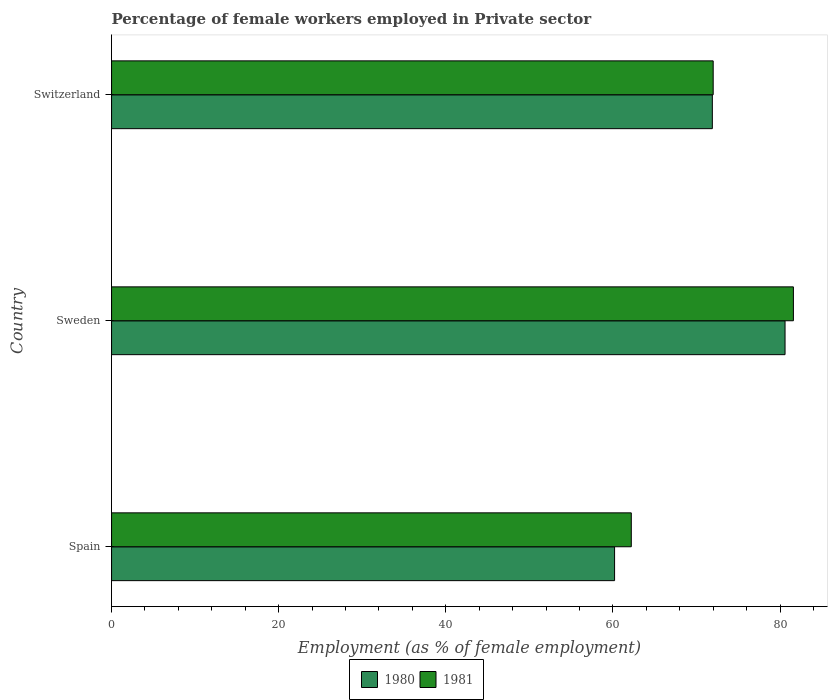How many different coloured bars are there?
Your response must be concise. 2. Are the number of bars per tick equal to the number of legend labels?
Ensure brevity in your answer.  Yes. Are the number of bars on each tick of the Y-axis equal?
Provide a short and direct response. Yes. How many bars are there on the 3rd tick from the top?
Provide a short and direct response. 2. What is the label of the 3rd group of bars from the top?
Your answer should be very brief. Spain. In how many cases, is the number of bars for a given country not equal to the number of legend labels?
Ensure brevity in your answer.  0. What is the percentage of females employed in Private sector in 1981 in Sweden?
Provide a short and direct response. 81.6. Across all countries, what is the maximum percentage of females employed in Private sector in 1981?
Give a very brief answer. 81.6. Across all countries, what is the minimum percentage of females employed in Private sector in 1981?
Your response must be concise. 62.2. What is the total percentage of females employed in Private sector in 1981 in the graph?
Provide a succinct answer. 215.8. What is the difference between the percentage of females employed in Private sector in 1980 in Spain and that in Sweden?
Make the answer very short. -20.4. What is the difference between the percentage of females employed in Private sector in 1981 in Spain and the percentage of females employed in Private sector in 1980 in Sweden?
Your response must be concise. -18.4. What is the average percentage of females employed in Private sector in 1981 per country?
Make the answer very short. 71.93. What is the difference between the percentage of females employed in Private sector in 1981 and percentage of females employed in Private sector in 1980 in Switzerland?
Ensure brevity in your answer.  0.1. In how many countries, is the percentage of females employed in Private sector in 1980 greater than 56 %?
Ensure brevity in your answer.  3. What is the ratio of the percentage of females employed in Private sector in 1980 in Sweden to that in Switzerland?
Your answer should be compact. 1.12. Is the percentage of females employed in Private sector in 1980 in Sweden less than that in Switzerland?
Make the answer very short. No. What is the difference between the highest and the second highest percentage of females employed in Private sector in 1980?
Your answer should be compact. 8.7. What is the difference between the highest and the lowest percentage of females employed in Private sector in 1981?
Keep it short and to the point. 19.4. In how many countries, is the percentage of females employed in Private sector in 1980 greater than the average percentage of females employed in Private sector in 1980 taken over all countries?
Make the answer very short. 2. Is the sum of the percentage of females employed in Private sector in 1980 in Spain and Switzerland greater than the maximum percentage of females employed in Private sector in 1981 across all countries?
Your response must be concise. Yes. Are all the bars in the graph horizontal?
Provide a succinct answer. Yes. What is the difference between two consecutive major ticks on the X-axis?
Give a very brief answer. 20. Does the graph contain any zero values?
Provide a succinct answer. No. Does the graph contain grids?
Offer a very short reply. No. How many legend labels are there?
Your answer should be very brief. 2. What is the title of the graph?
Your response must be concise. Percentage of female workers employed in Private sector. What is the label or title of the X-axis?
Provide a succinct answer. Employment (as % of female employment). What is the Employment (as % of female employment) in 1980 in Spain?
Provide a succinct answer. 60.2. What is the Employment (as % of female employment) in 1981 in Spain?
Offer a very short reply. 62.2. What is the Employment (as % of female employment) in 1980 in Sweden?
Give a very brief answer. 80.6. What is the Employment (as % of female employment) in 1981 in Sweden?
Your response must be concise. 81.6. What is the Employment (as % of female employment) in 1980 in Switzerland?
Offer a very short reply. 71.9. Across all countries, what is the maximum Employment (as % of female employment) of 1980?
Provide a succinct answer. 80.6. Across all countries, what is the maximum Employment (as % of female employment) in 1981?
Your answer should be very brief. 81.6. Across all countries, what is the minimum Employment (as % of female employment) in 1980?
Offer a terse response. 60.2. Across all countries, what is the minimum Employment (as % of female employment) in 1981?
Offer a very short reply. 62.2. What is the total Employment (as % of female employment) in 1980 in the graph?
Keep it short and to the point. 212.7. What is the total Employment (as % of female employment) of 1981 in the graph?
Offer a very short reply. 215.8. What is the difference between the Employment (as % of female employment) in 1980 in Spain and that in Sweden?
Provide a short and direct response. -20.4. What is the difference between the Employment (as % of female employment) in 1981 in Spain and that in Sweden?
Provide a short and direct response. -19.4. What is the difference between the Employment (as % of female employment) of 1980 in Spain and that in Switzerland?
Offer a terse response. -11.7. What is the difference between the Employment (as % of female employment) of 1980 in Sweden and that in Switzerland?
Offer a terse response. 8.7. What is the difference between the Employment (as % of female employment) of 1981 in Sweden and that in Switzerland?
Provide a succinct answer. 9.6. What is the difference between the Employment (as % of female employment) in 1980 in Spain and the Employment (as % of female employment) in 1981 in Sweden?
Offer a terse response. -21.4. What is the difference between the Employment (as % of female employment) of 1980 in Spain and the Employment (as % of female employment) of 1981 in Switzerland?
Offer a terse response. -11.8. What is the average Employment (as % of female employment) of 1980 per country?
Make the answer very short. 70.9. What is the average Employment (as % of female employment) of 1981 per country?
Offer a terse response. 71.93. What is the difference between the Employment (as % of female employment) of 1980 and Employment (as % of female employment) of 1981 in Spain?
Provide a succinct answer. -2. What is the difference between the Employment (as % of female employment) of 1980 and Employment (as % of female employment) of 1981 in Sweden?
Provide a short and direct response. -1. What is the difference between the Employment (as % of female employment) in 1980 and Employment (as % of female employment) in 1981 in Switzerland?
Your answer should be compact. -0.1. What is the ratio of the Employment (as % of female employment) in 1980 in Spain to that in Sweden?
Ensure brevity in your answer.  0.75. What is the ratio of the Employment (as % of female employment) of 1981 in Spain to that in Sweden?
Your answer should be compact. 0.76. What is the ratio of the Employment (as % of female employment) in 1980 in Spain to that in Switzerland?
Give a very brief answer. 0.84. What is the ratio of the Employment (as % of female employment) in 1981 in Spain to that in Switzerland?
Make the answer very short. 0.86. What is the ratio of the Employment (as % of female employment) of 1980 in Sweden to that in Switzerland?
Your response must be concise. 1.12. What is the ratio of the Employment (as % of female employment) in 1981 in Sweden to that in Switzerland?
Your answer should be compact. 1.13. What is the difference between the highest and the second highest Employment (as % of female employment) of 1980?
Keep it short and to the point. 8.7. What is the difference between the highest and the second highest Employment (as % of female employment) of 1981?
Your response must be concise. 9.6. What is the difference between the highest and the lowest Employment (as % of female employment) in 1980?
Keep it short and to the point. 20.4. 